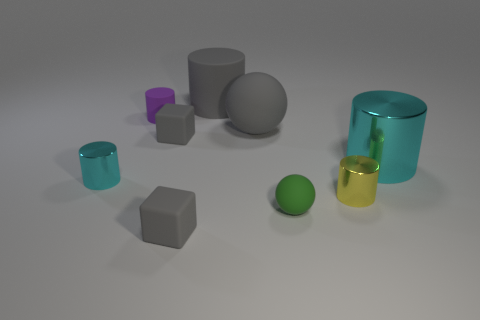Subtract all big metal cylinders. How many cylinders are left? 4 Subtract all brown cylinders. Subtract all red spheres. How many cylinders are left? 5 Add 1 green rubber balls. How many objects exist? 10 Subtract all cylinders. How many objects are left? 4 Subtract all small matte spheres. Subtract all big purple matte cubes. How many objects are left? 8 Add 4 small purple matte things. How many small purple matte things are left? 5 Add 5 cyan cylinders. How many cyan cylinders exist? 7 Subtract 0 purple cubes. How many objects are left? 9 